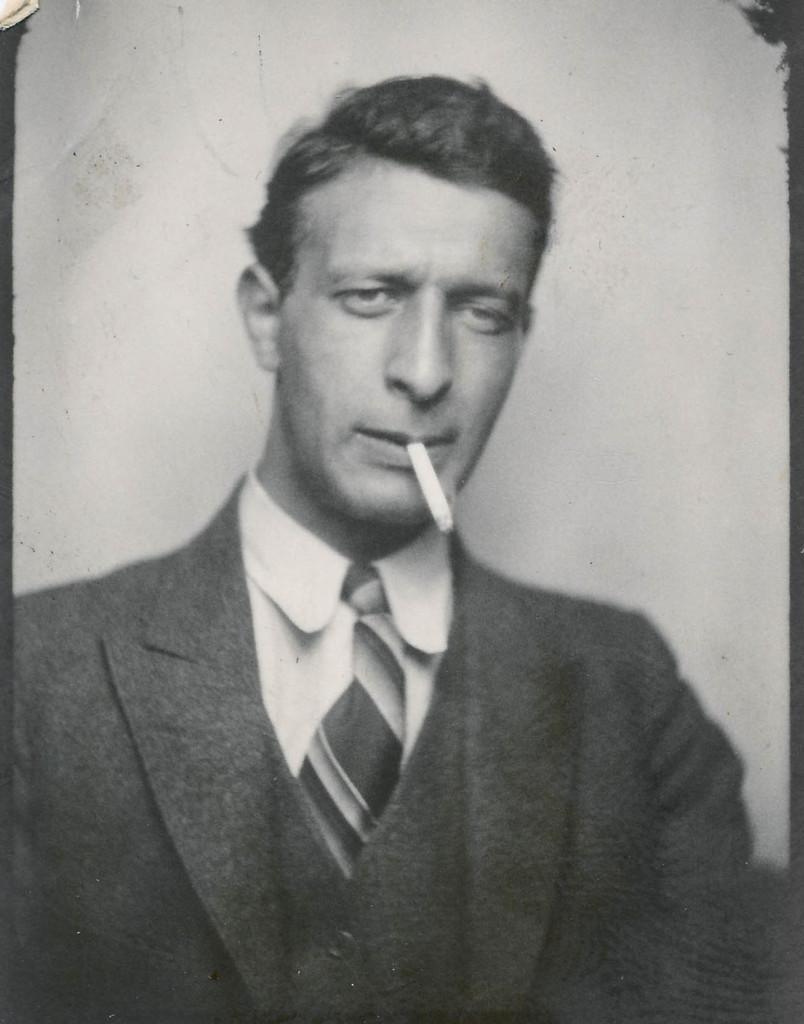What is the main object in the image? There is a frame in the image. What is happening inside the frame? A person is standing inside the frame. What is the person doing? The person is smoking. How many cats can be seen playing on the trail in the image? There are no cats or trails present in the image. What type of operation is being performed on the person in the image? There is no operation being performed on the person in the image; they are simply standing and smoking. 